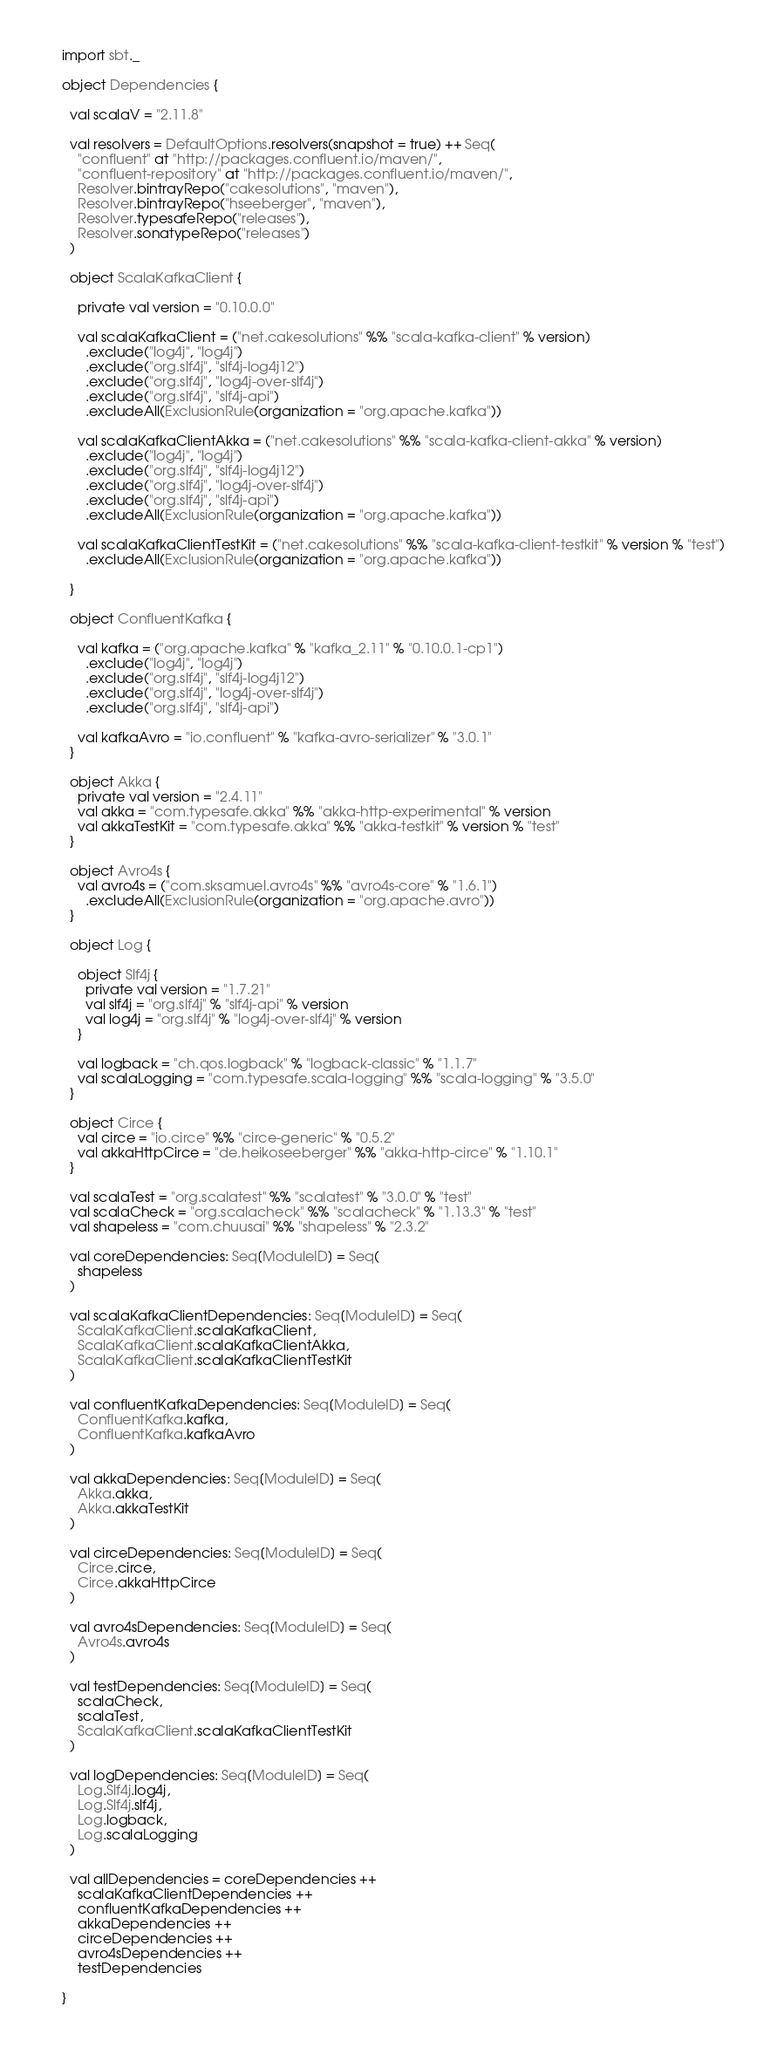<code> <loc_0><loc_0><loc_500><loc_500><_Scala_>import sbt._

object Dependencies {

  val scalaV = "2.11.8"

  val resolvers = DefaultOptions.resolvers(snapshot = true) ++ Seq(
    "confluent" at "http://packages.confluent.io/maven/",
    "confluent-repository" at "http://packages.confluent.io/maven/",
    Resolver.bintrayRepo("cakesolutions", "maven"),
    Resolver.bintrayRepo("hseeberger", "maven"),
    Resolver.typesafeRepo("releases"),
    Resolver.sonatypeRepo("releases")
  )

  object ScalaKafkaClient {

    private val version = "0.10.0.0"

    val scalaKafkaClient = ("net.cakesolutions" %% "scala-kafka-client" % version)
      .exclude("log4j", "log4j")
      .exclude("org.slf4j", "slf4j-log4j12")
      .exclude("org.slf4j", "log4j-over-slf4j")
      .exclude("org.slf4j", "slf4j-api")
      .excludeAll(ExclusionRule(organization = "org.apache.kafka"))

    val scalaKafkaClientAkka = ("net.cakesolutions" %% "scala-kafka-client-akka" % version)
      .exclude("log4j", "log4j")
      .exclude("org.slf4j", "slf4j-log4j12")
      .exclude("org.slf4j", "log4j-over-slf4j")
      .exclude("org.slf4j", "slf4j-api")
      .excludeAll(ExclusionRule(organization = "org.apache.kafka"))

    val scalaKafkaClientTestKit = ("net.cakesolutions" %% "scala-kafka-client-testkit" % version % "test")
      .excludeAll(ExclusionRule(organization = "org.apache.kafka"))

  }

  object ConfluentKafka {

    val kafka = ("org.apache.kafka" % "kafka_2.11" % "0.10.0.1-cp1")
      .exclude("log4j", "log4j")
      .exclude("org.slf4j", "slf4j-log4j12")
      .exclude("org.slf4j", "log4j-over-slf4j")
      .exclude("org.slf4j", "slf4j-api")

    val kafkaAvro = "io.confluent" % "kafka-avro-serializer" % "3.0.1"
  }

  object Akka {
    private val version = "2.4.11"
    val akka = "com.typesafe.akka" %% "akka-http-experimental" % version
    val akkaTestKit = "com.typesafe.akka" %% "akka-testkit" % version % "test"
  }

  object Avro4s {
    val avro4s = ("com.sksamuel.avro4s" %% "avro4s-core" % "1.6.1")
      .excludeAll(ExclusionRule(organization = "org.apache.avro"))
  }

  object Log {

    object Slf4j {
      private val version = "1.7.21"
      val slf4j = "org.slf4j" % "slf4j-api" % version
      val log4j = "org.slf4j" % "log4j-over-slf4j" % version
    }

    val logback = "ch.qos.logback" % "logback-classic" % "1.1.7"
    val scalaLogging = "com.typesafe.scala-logging" %% "scala-logging" % "3.5.0"
  }

  object Circe {
    val circe = "io.circe" %% "circe-generic" % "0.5.2"
    val akkaHttpCirce = "de.heikoseeberger" %% "akka-http-circe" % "1.10.1"
  }

  val scalaTest = "org.scalatest" %% "scalatest" % "3.0.0" % "test"
  val scalaCheck = "org.scalacheck" %% "scalacheck" % "1.13.3" % "test"
  val shapeless = "com.chuusai" %% "shapeless" % "2.3.2"

  val coreDependencies: Seq[ModuleID] = Seq(
    shapeless
  )

  val scalaKafkaClientDependencies: Seq[ModuleID] = Seq(
    ScalaKafkaClient.scalaKafkaClient,
    ScalaKafkaClient.scalaKafkaClientAkka,
    ScalaKafkaClient.scalaKafkaClientTestKit
  )

  val confluentKafkaDependencies: Seq[ModuleID] = Seq(
    ConfluentKafka.kafka,
    ConfluentKafka.kafkaAvro
  )

  val akkaDependencies: Seq[ModuleID] = Seq(
    Akka.akka,
    Akka.akkaTestKit
  )

  val circeDependencies: Seq[ModuleID] = Seq(
    Circe.circe,
    Circe.akkaHttpCirce
  )

  val avro4sDependencies: Seq[ModuleID] = Seq(
    Avro4s.avro4s
  )

  val testDependencies: Seq[ModuleID] = Seq(
    scalaCheck,
    scalaTest,
    ScalaKafkaClient.scalaKafkaClientTestKit
  )

  val logDependencies: Seq[ModuleID] = Seq(
    Log.Slf4j.log4j,
    Log.Slf4j.slf4j,
    Log.logback,
    Log.scalaLogging
  )

  val allDependencies = coreDependencies ++
    scalaKafkaClientDependencies ++
    confluentKafkaDependencies ++
    akkaDependencies ++
    circeDependencies ++
    avro4sDependencies ++
    testDependencies

}</code> 